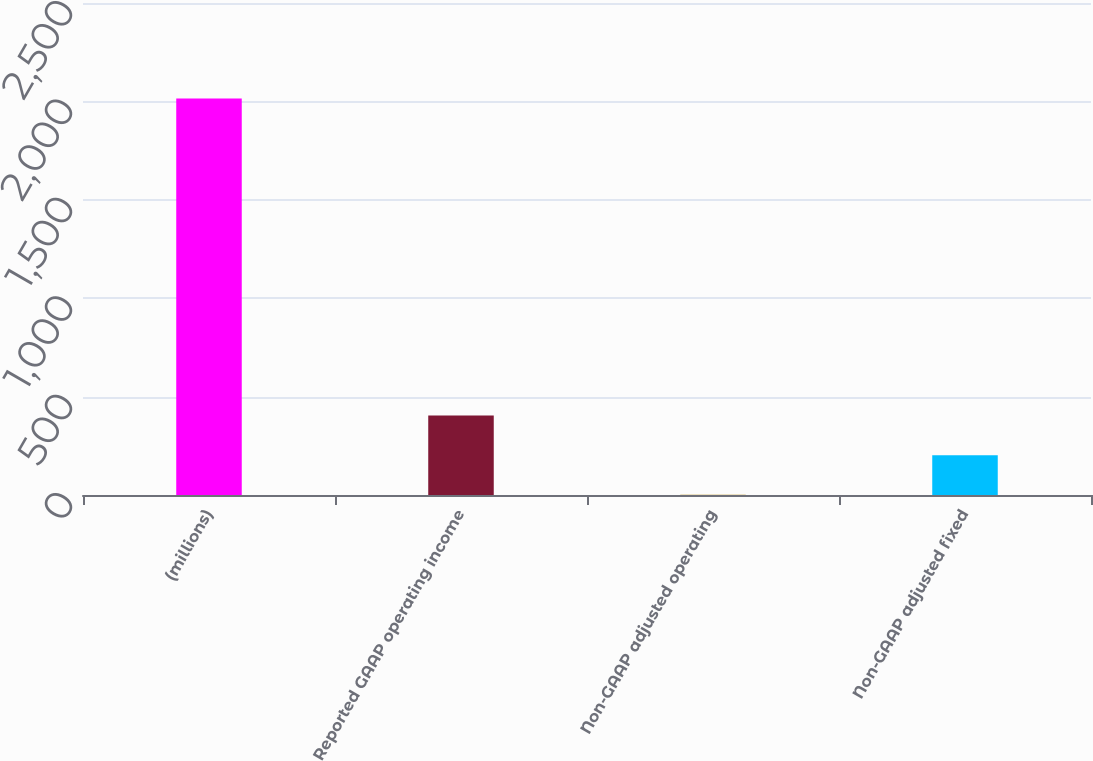Convert chart to OTSL. <chart><loc_0><loc_0><loc_500><loc_500><bar_chart><fcel>(millions)<fcel>Reported GAAP operating income<fcel>Non-GAAP adjusted operating<fcel>Non-GAAP adjusted fixed<nl><fcel>2015<fcel>403.8<fcel>1<fcel>202.4<nl></chart> 